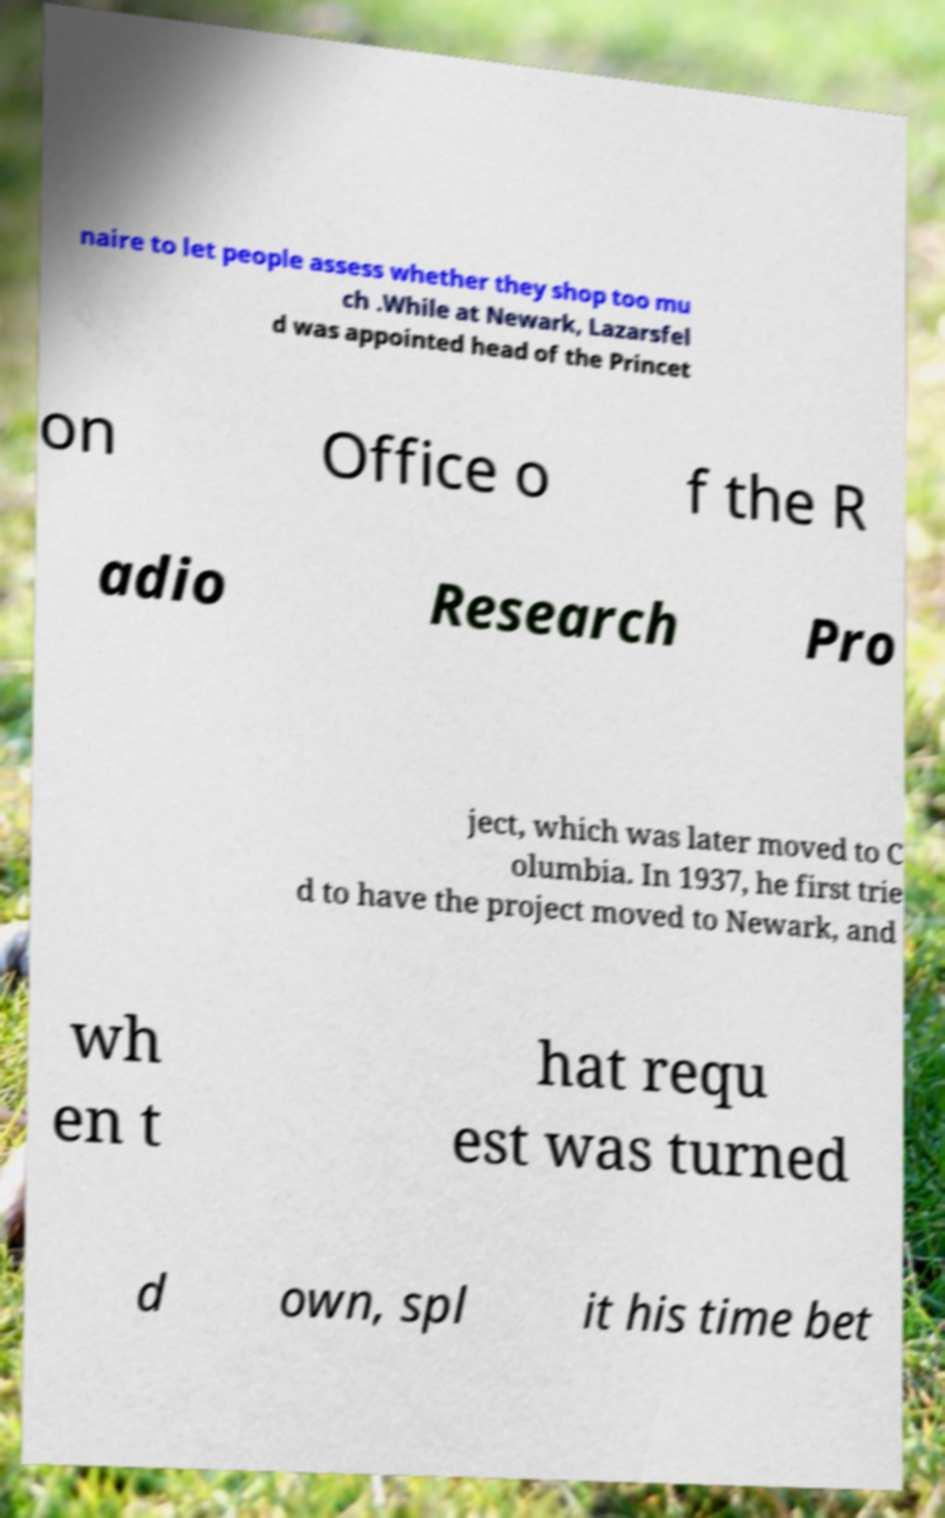Please identify and transcribe the text found in this image. naire to let people assess whether they shop too mu ch .While at Newark, Lazarsfel d was appointed head of the Princet on Office o f the R adio Research Pro ject, which was later moved to C olumbia. In 1937, he first trie d to have the project moved to Newark, and wh en t hat requ est was turned d own, spl it his time bet 